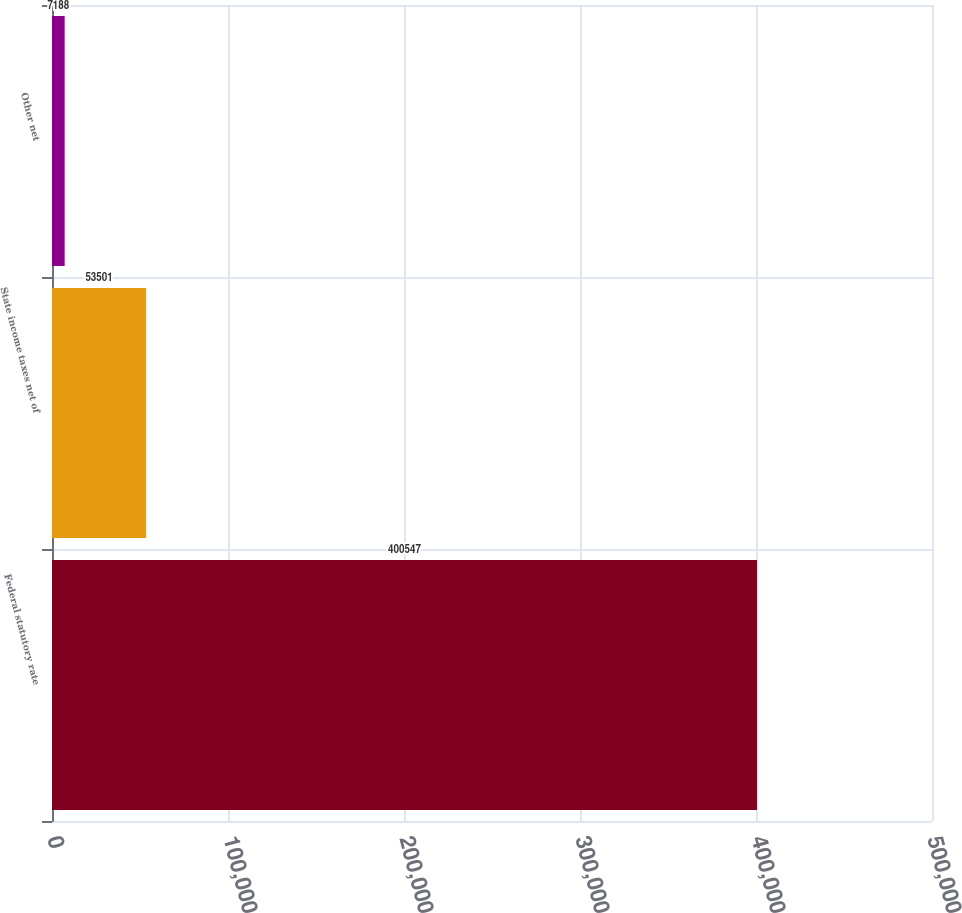<chart> <loc_0><loc_0><loc_500><loc_500><bar_chart><fcel>Federal statutory rate<fcel>State income taxes net of<fcel>Other net<nl><fcel>400547<fcel>53501<fcel>7188<nl></chart> 